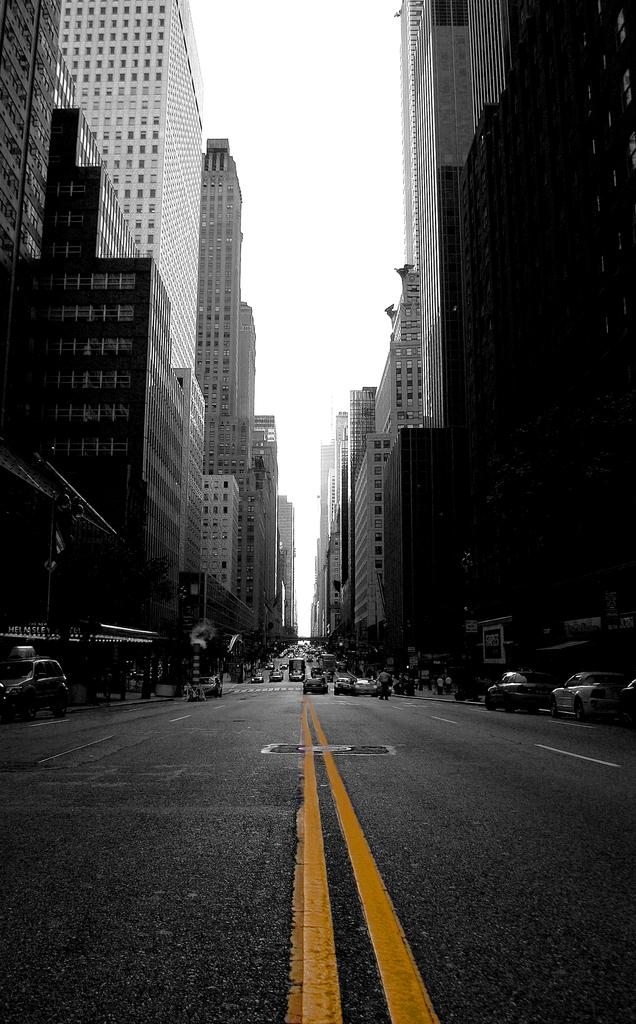What is the color scheme of the image? The image is black and white. What can be seen on the road in the image? There are vehicles on the road in the image. What type of structures are present in the image? There are buildings in the image. What type of sun can be seen in the image? There is no sun present in the image, as it is a black and white image. What type of land is visible in the image? The image does not show any specific type of land; it only shows vehicles on the road and buildings. 